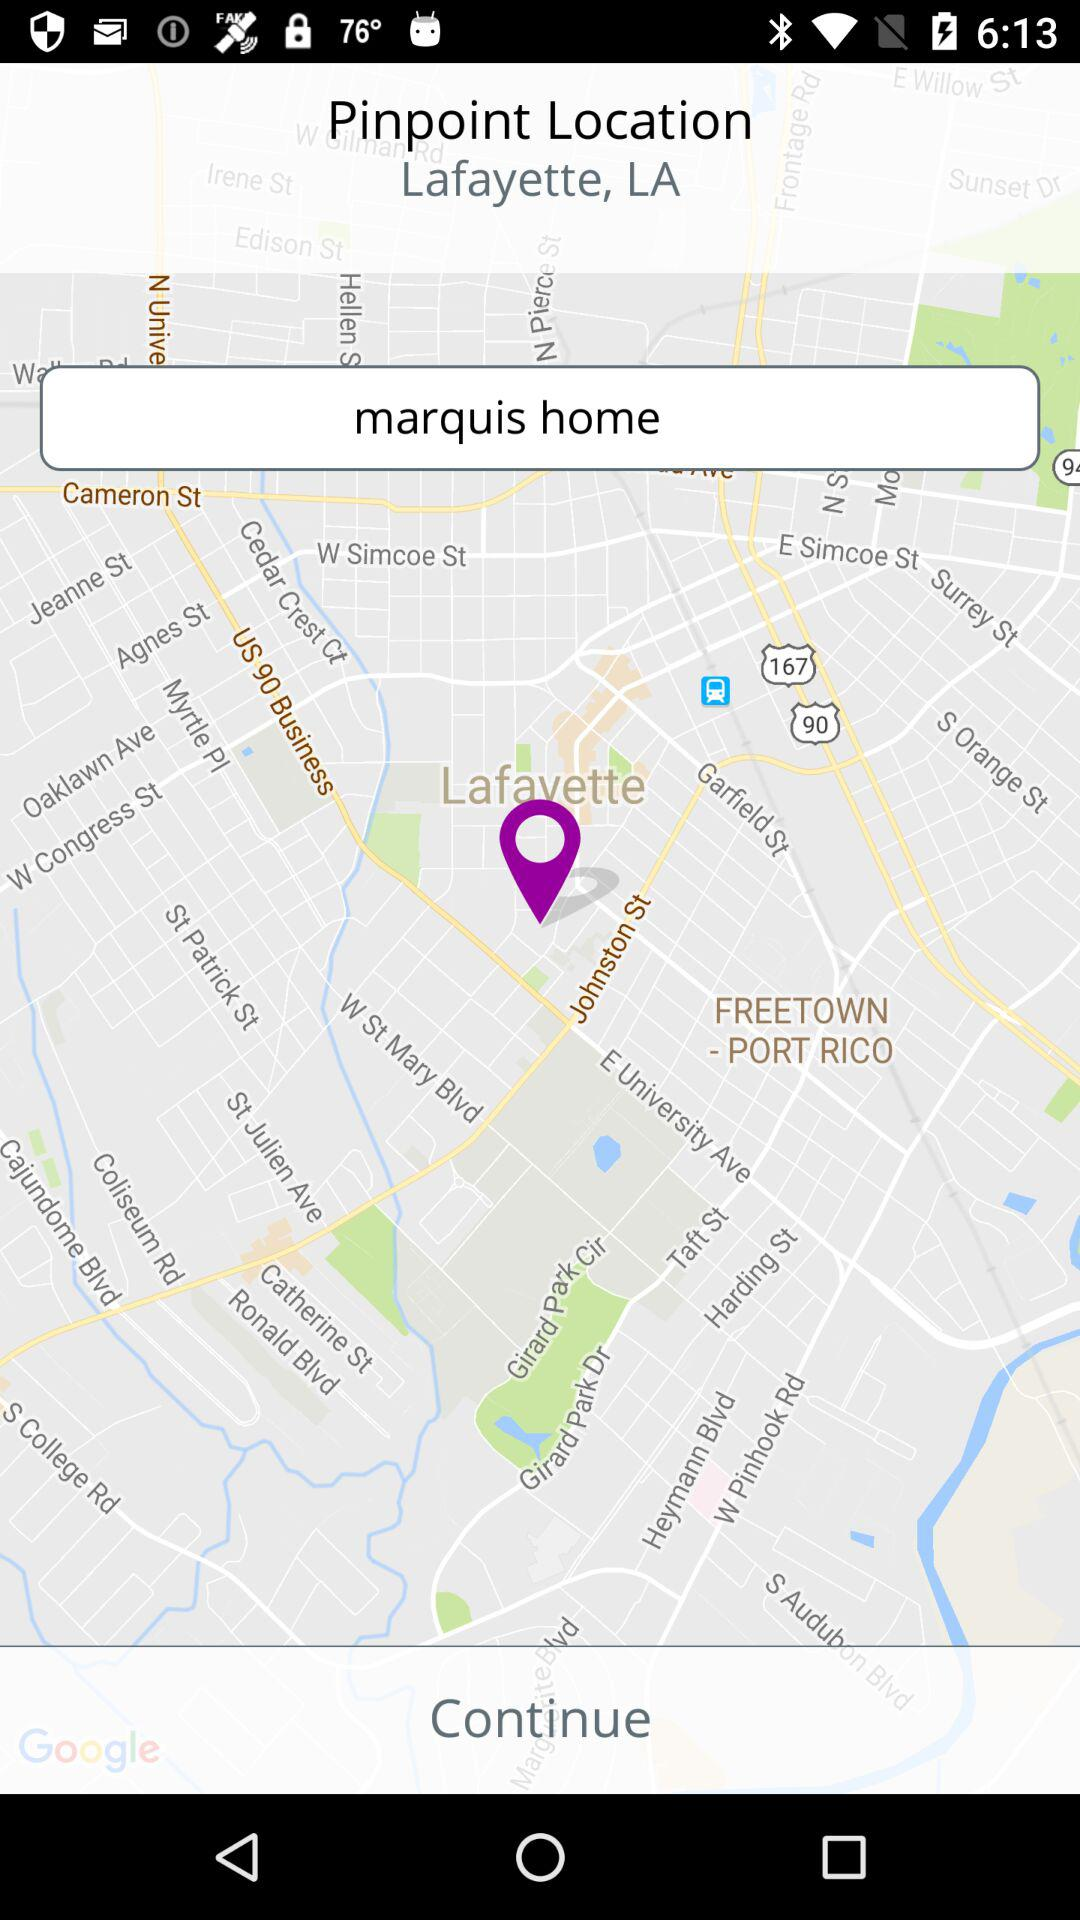What's the pinpoint location? The pinpoint location is Lafayette, LA. 